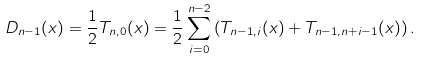<formula> <loc_0><loc_0><loc_500><loc_500>D _ { n - 1 } ( x ) = \frac { 1 } { 2 } T _ { n , 0 } ( x ) = \frac { 1 } { 2 } \sum _ { i = 0 } ^ { n - 2 } \left ( T _ { n - 1 , i } ( x ) + T _ { n - 1 , n + i - 1 } ( x ) \right ) .</formula> 